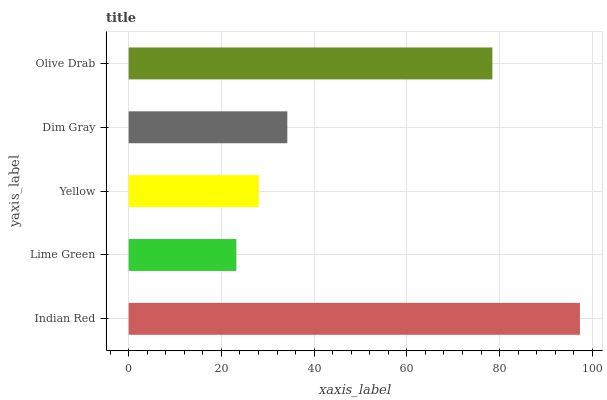Is Lime Green the minimum?
Answer yes or no. Yes. Is Indian Red the maximum?
Answer yes or no. Yes. Is Yellow the minimum?
Answer yes or no. No. Is Yellow the maximum?
Answer yes or no. No. Is Yellow greater than Lime Green?
Answer yes or no. Yes. Is Lime Green less than Yellow?
Answer yes or no. Yes. Is Lime Green greater than Yellow?
Answer yes or no. No. Is Yellow less than Lime Green?
Answer yes or no. No. Is Dim Gray the high median?
Answer yes or no. Yes. Is Dim Gray the low median?
Answer yes or no. Yes. Is Olive Drab the high median?
Answer yes or no. No. Is Indian Red the low median?
Answer yes or no. No. 